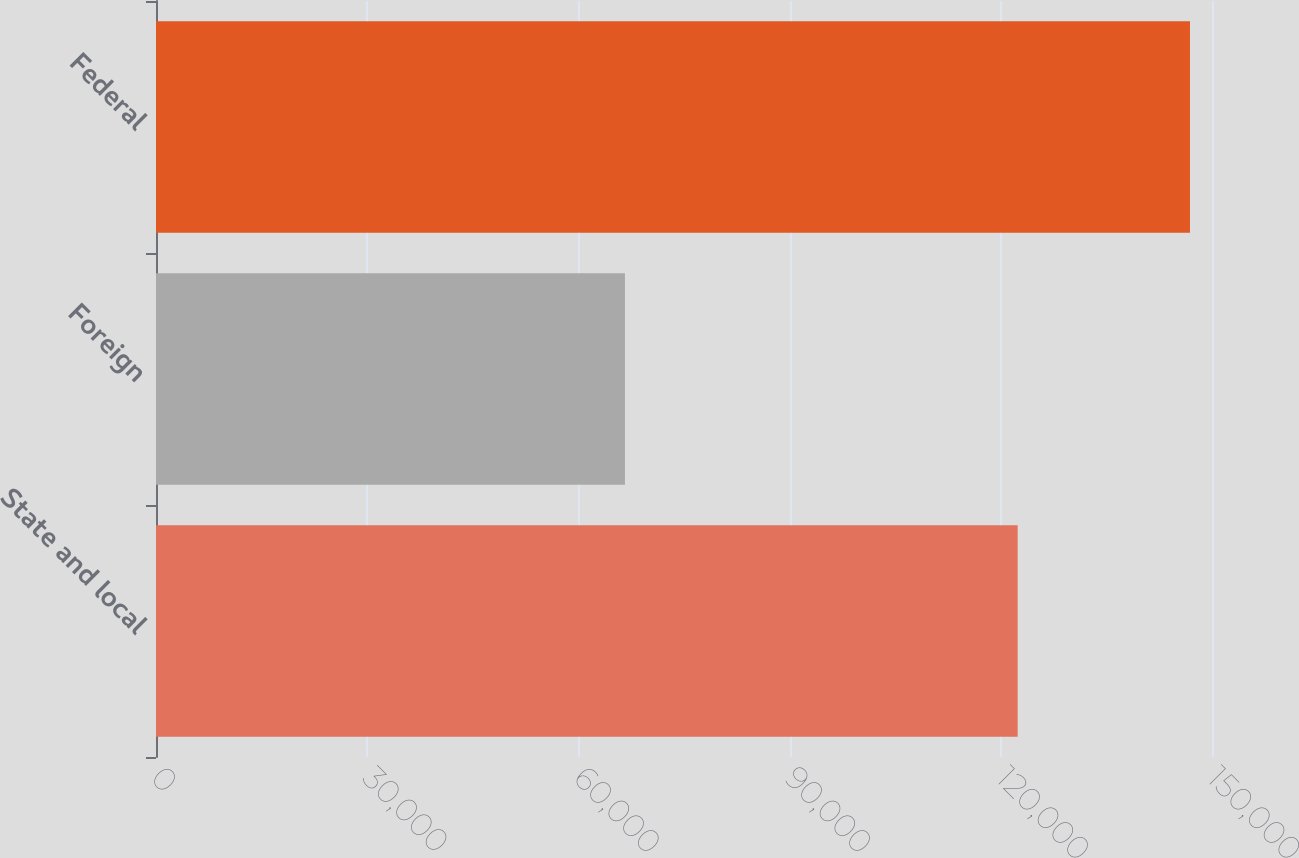Convert chart to OTSL. <chart><loc_0><loc_0><loc_500><loc_500><bar_chart><fcel>State and local<fcel>Foreign<fcel>Federal<nl><fcel>122396<fcel>66610<fcel>146872<nl></chart> 